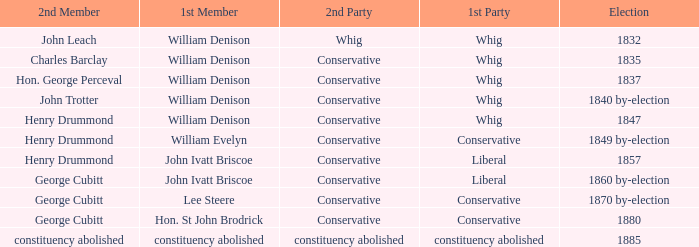Which party's 1st member is William Denison in the election of 1832? Whig. 